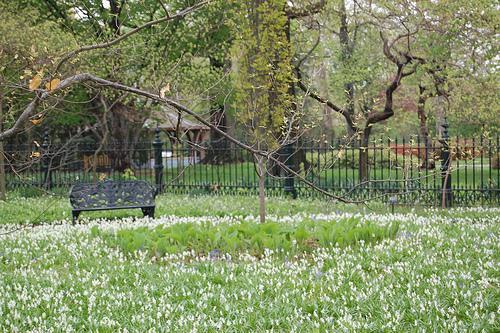How many people are sitting on the grass?
Give a very brief answer. 0. 